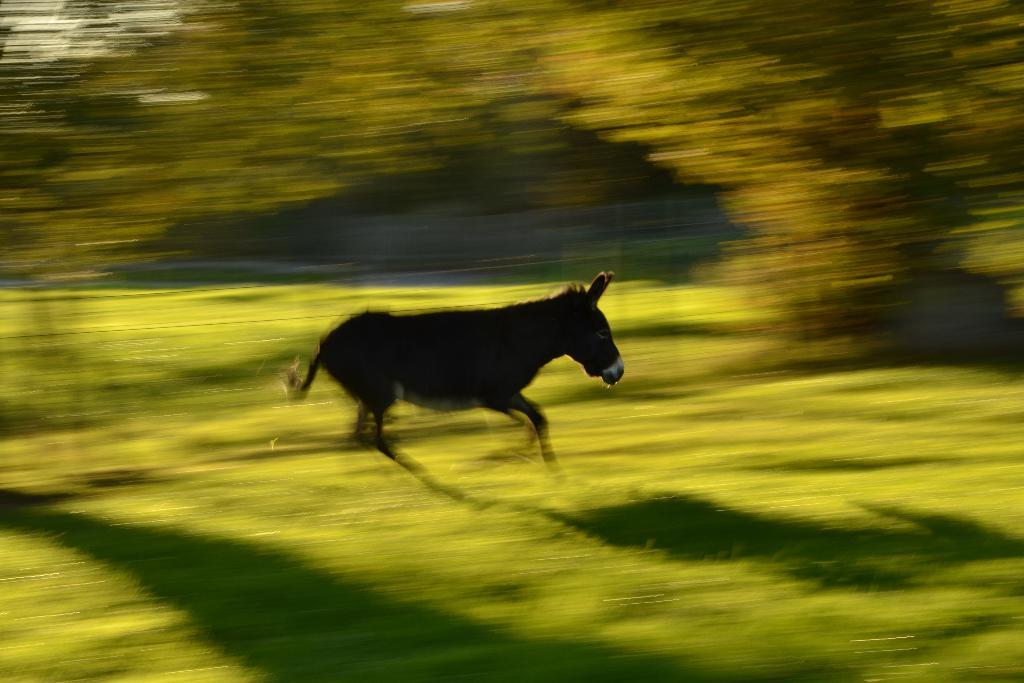What type of animal is in the image? The animal in the image has black, brown, and white colors, but the specific type cannot be determined from the provided facts. What colors are present in the background of the image? The background of the image is green and yellow. How is the background of the image depicted? The background is blurred. What type of pain is the animal experiencing in the image? There is no indication in the image that the animal is experiencing any pain. Are there any giants visible in the image? There are no giants present in the image. 